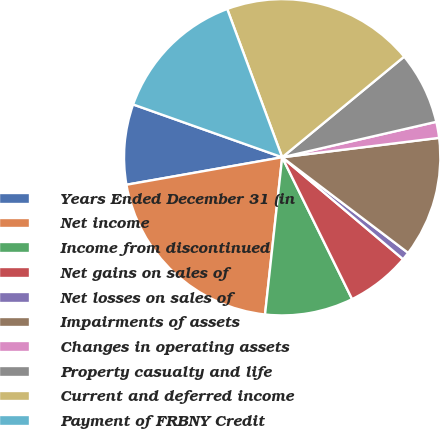Convert chart to OTSL. <chart><loc_0><loc_0><loc_500><loc_500><pie_chart><fcel>Years Ended December 31 (in<fcel>Net income<fcel>Income from discontinued<fcel>Net gains on sales of<fcel>Net losses on sales of<fcel>Impairments of assets<fcel>Changes in operating assets<fcel>Property casualty and life<fcel>Current and deferred income<fcel>Payment of FRBNY Credit<nl><fcel>8.2%<fcel>20.49%<fcel>9.02%<fcel>6.56%<fcel>0.82%<fcel>12.29%<fcel>1.64%<fcel>7.38%<fcel>19.67%<fcel>13.93%<nl></chart> 